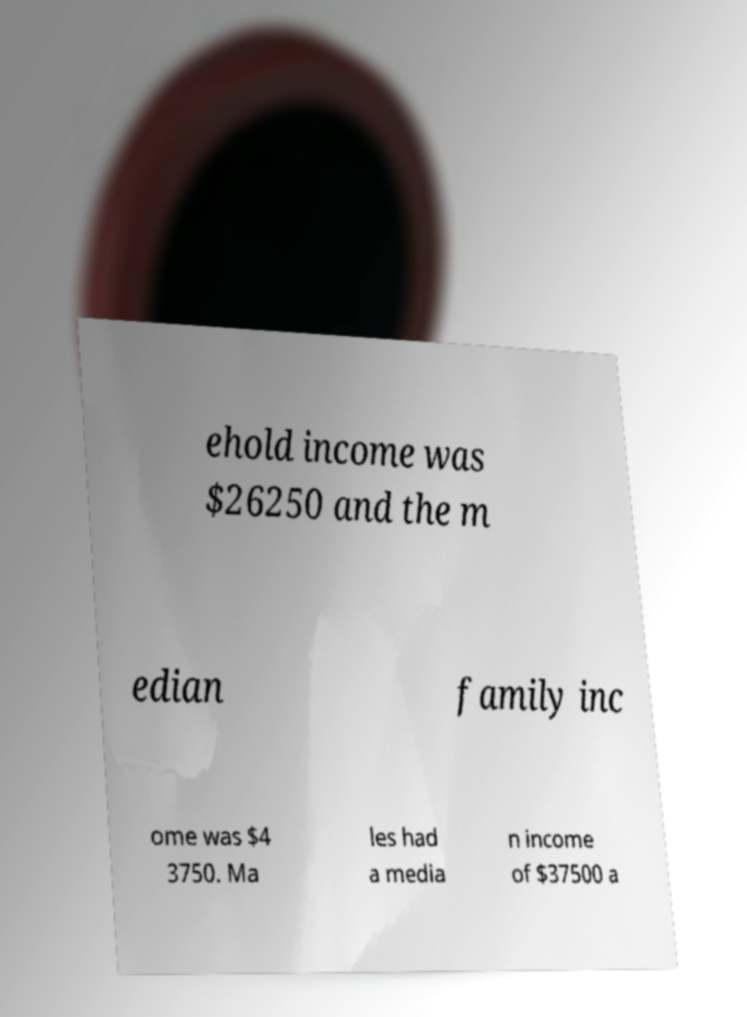Could you assist in decoding the text presented in this image and type it out clearly? ehold income was $26250 and the m edian family inc ome was $4 3750. Ma les had a media n income of $37500 a 